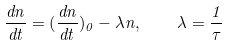Convert formula to latex. <formula><loc_0><loc_0><loc_500><loc_500>\frac { d n } { d t } = { ( { \frac { d n } { d t } } ) _ { 0 } } - { \lambda } n , \quad \lambda = { \frac { 1 } { \tau } }</formula> 